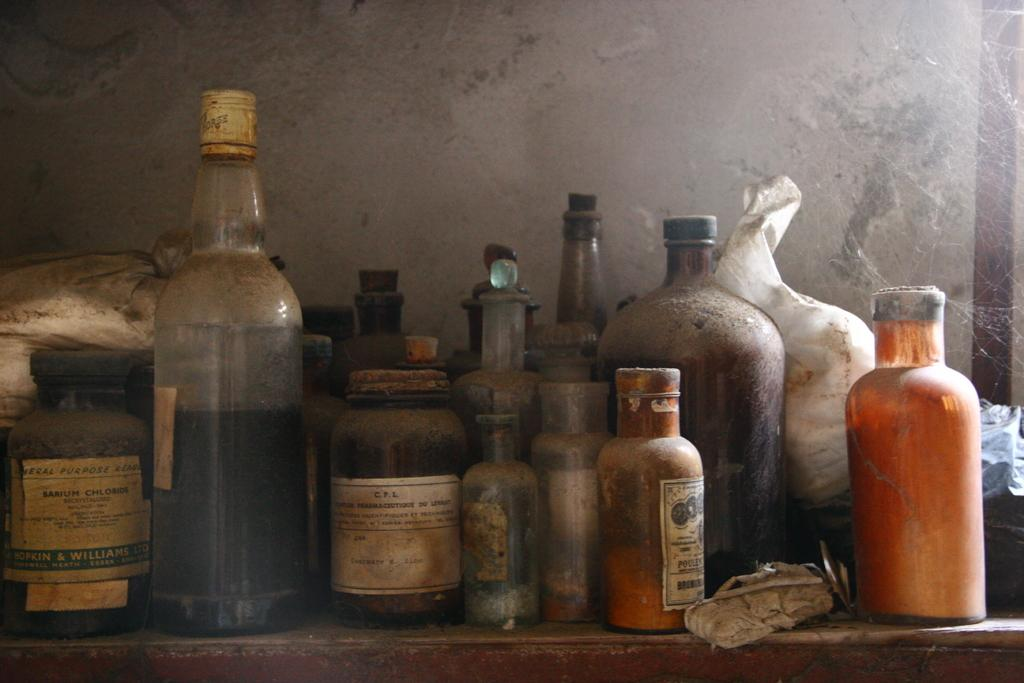What is the color and size of the table in the image? There is a big table of brown color in the image. What objects are on the table? There are bottles and white bags on the table. What color is the wall in the background of the image? The background of the image includes a white color wall. What type of trade is being conducted in the image? There is no indication of any trade being conducted in the image; it simply shows a table with bottles and white bags. How many arms are visible in the image? There are no arms visible in the image; it only shows a table with objects on it and a white wall in the background. 